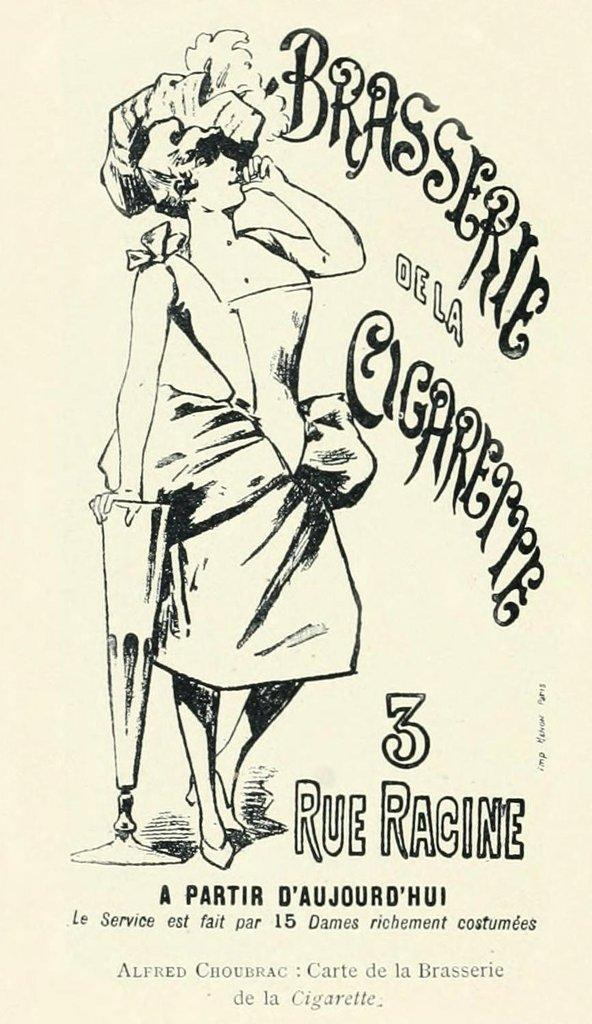What is depicted in the sketch? There is a person in the sketch. What is the person doing in the sketch? The person is standing in the sketch. What is the person holding in the sketch? The person is holding a stand in the sketch. Is there any text present in the sketch? Yes, there is text written in the sketch. What type of wool is being used to create the chair in the sketch? There is no chair present in the sketch, and therefore no wool is being used to create it. 